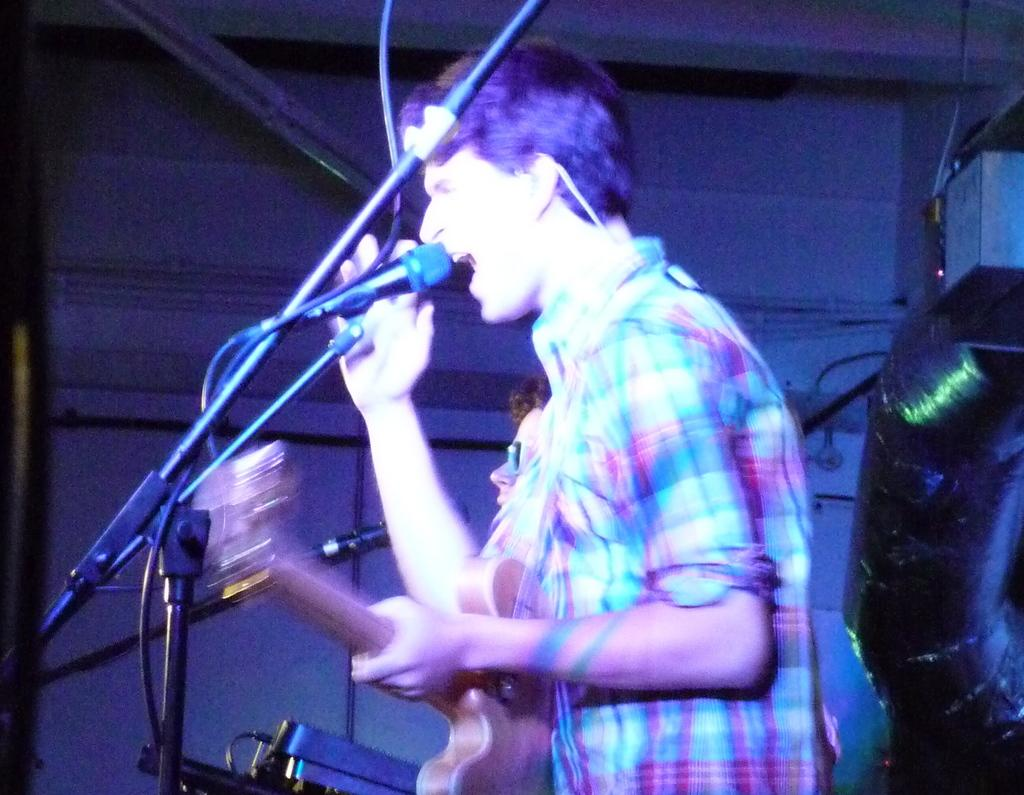How many people are in the image? There are two persons in the image. What are the persons doing in the image? The persons are standing and holding musical instruments. What else are the persons holding in the image? The persons are also holding microphones. What can be seen in the background of the image? There is a wall in the background of the image. Can you tell me how many monkeys are sitting on the wall in the image? There are no monkeys present in the image; it features two persons holding musical instruments and microphones. 